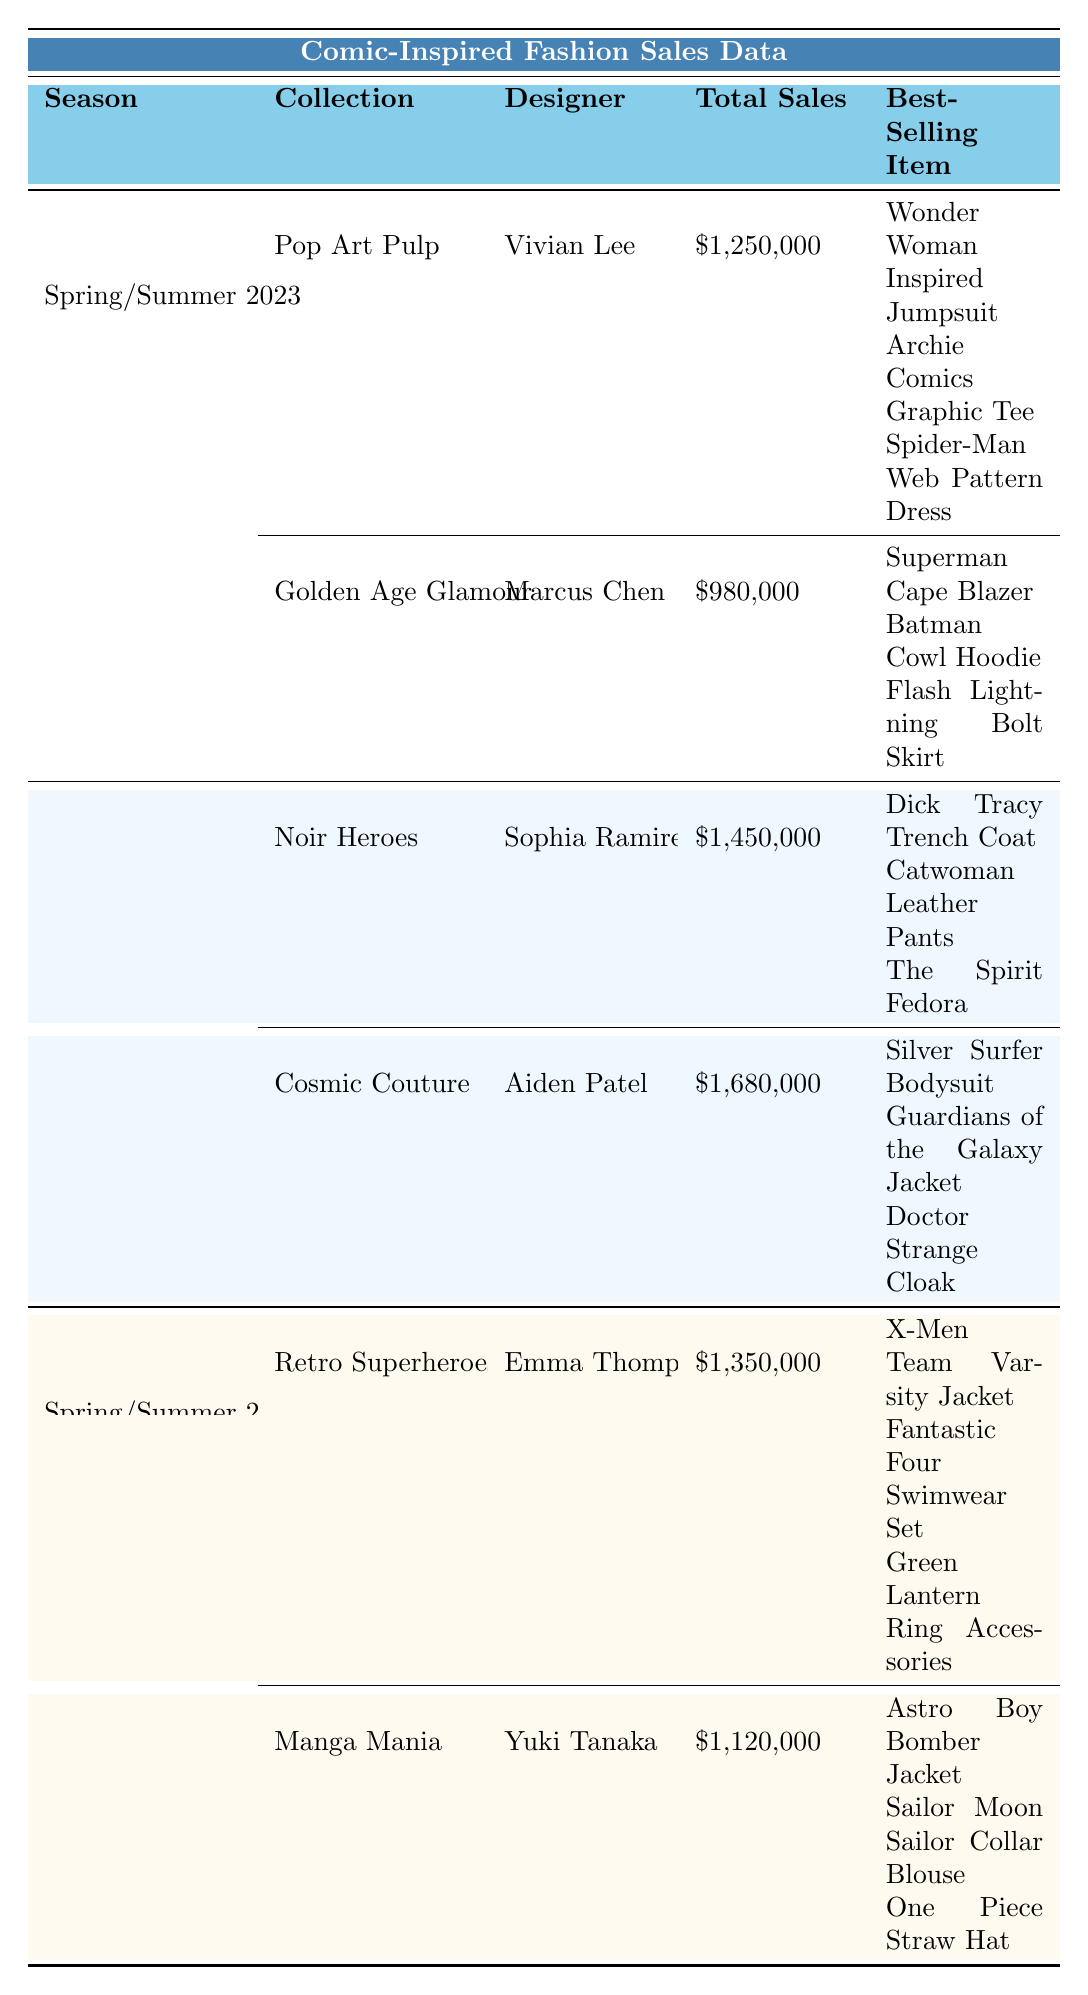What is the total sales for the Winter 2023 season? In the table, the total sales for Fall/Winter 2023 is presented. The total sales for the "Noir Heroes" collection is $1,450,000 and for "Cosmic Couture" it is $1,680,000. Therefore, adding these two amounts gives $1,450,000 + $1,680,000 = $3,130,000.
Answer: $3,130,000 Which collection had the highest total sales and who was the designer? Reviewing the total sales data for all seasons, the "Cosmic Couture" collection has the highest total sales of $1,680,000, and the designer of this collection is Aiden Patel.
Answer: Cosmic Couture by Aiden Patel How many units of the "Astro Boy Bomber Jacket" were sold? The best-selling items for "Manga Mania" collection are listed, where the "Astro Boy Bomber Jacket" specifically shows it sold 2,800 units.
Answer: 2,800 units Which designer created the "Superman Cape Blazer"? By examining the "Spring/Summer 2023" section, the "Superman Cape Blazer" is linked to the "Golden Age Glamour" collection, which was designed by Marcus Chen.
Answer: Marcus Chen What is the total revenue for the best-selling item in each collection? The best-selling items and their revenues from each collection should be summed. For "Pop Art Pulp", $525,000 from "Wonder Woman Inspired Jumpsuit"; "Golden Age Glamour", $396,000 from "Superman Cape Blazer"; "Noir Heroes", $560,000 from "Dick Tracy Trench Coat"; "Cosmic Couture", $600,000 from "Silver Surfer Bodysuit"; "Retro Superheroes", $570,000 from "X-Men Team Varsity Jacket"; and "Manga Mania", $392,000 from "Astro Boy Bomber Jacket". Summing these revenues gives $525,000 + $396,000 + $560,000 + $600,000 + $570,000 + $392,000 = $3,043,000.
Answer: $3,043,000 How many units of "Guardians of the Galaxy Jacket" were sold? The "Guardians of the Galaxy Jacket" is listed under the best-selling items for the "Cosmic Couture" collection, which indicates that 2,500 units were sold.
Answer: 2,500 units What is the average total sales per collection for Spring/Summer 2023? There are two collections in Spring/Summer 2023 with total sales of $1,250,000 (Pop Art Pulp) and $980,000 (Golden Age Glamour). To find the average, sum these amounts: $1,250,000 + $980,000 = $2,230,000, then divide by the number of collections (2), which gives $2,230,000 / 2 = $1,115,000.
Answer: $1,115,000 Which collection had the lowest total sales in Spring/Summer 2024? Comparing the total sales for the collections in Spring/Summer 2024, "Manga Mania" at $1,120,000 is less than "Retro Superheroes" at $1,350,000, thus "Manga Mania" had the lowest.
Answer: Manga Mania Was the "Flash Lightning Bolt Skirt" a best-seller in the Summer 2023 season? In the table, "Flash Lightning Bolt Skirt" is listed under the "Golden Age Glamour" collection. Since it is mentioned as a best-selling item, the answer is yes.
Answer: Yes What designer has the highest total revenue from their collections combined? The total revenue for each designer is calculated by summing their collection sales. Vivian Lee (Pop Art Pulp $1,250,000) + Marcus Chen (Golden Age Glamour $980,000) = $2,230,000; Sophia Ramirez (Noir Heroes $1,450,000) + Aiden Patel (Cosmic Couture $1,680,000) = $3,130,000; Emma Thompson (Retro Superheroes $1,350,000) + Yuki Tanaka (Manga Mania $1,120,000) = $2,470,000. Aiden Patel has the highest with $3,130,000.
Answer: Aiden Patel Which item from the Fall/Winter 2023 collection had the highest revenue? Among the best-selling items from "Noir Heroes" and "Cosmic Couture", the "Silver Surfer Bodysuit" has the highest revenue of $600,000 in the "Cosmic Couture" collection compared to others.
Answer: Silver Surfer Bodysuit 